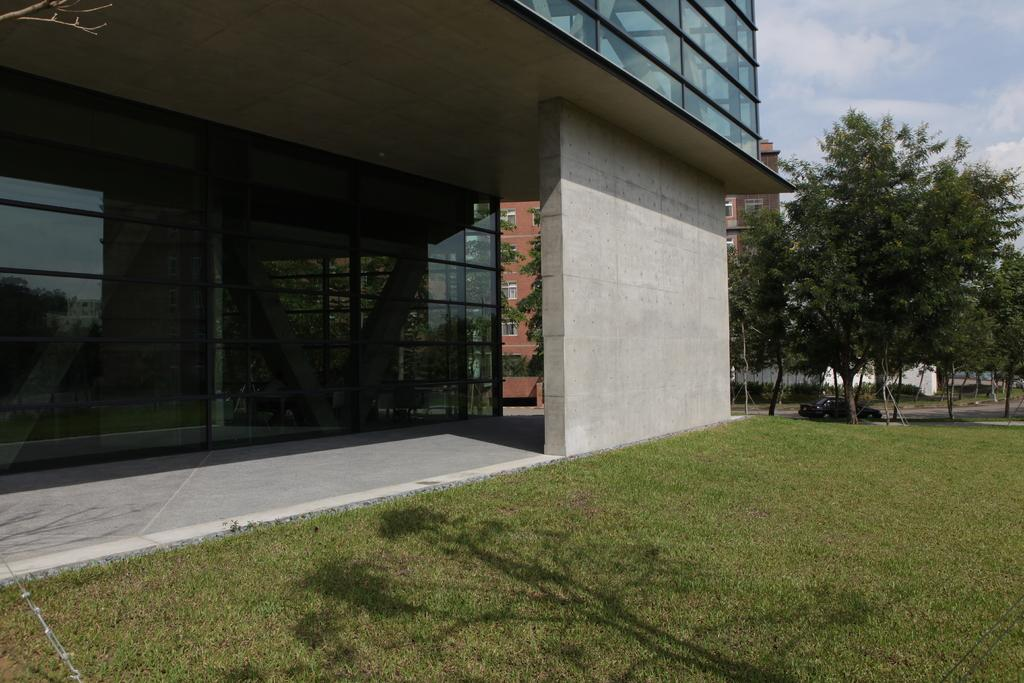What type of vegetation is on the right side of the image? There are trees on the right side of the image. What mode of transportation can be seen on the road in the image? There is a car on the road in the image. What is visible at the top of the image? The sky is visible at the top of the image. What type of structures are on the left side of the image? There are buildings on the left side of the image. What type of education is being discussed in the image? There is no discussion or reference to education in the image. What type of pet can be seen in the image? There is no pet present in the image. 